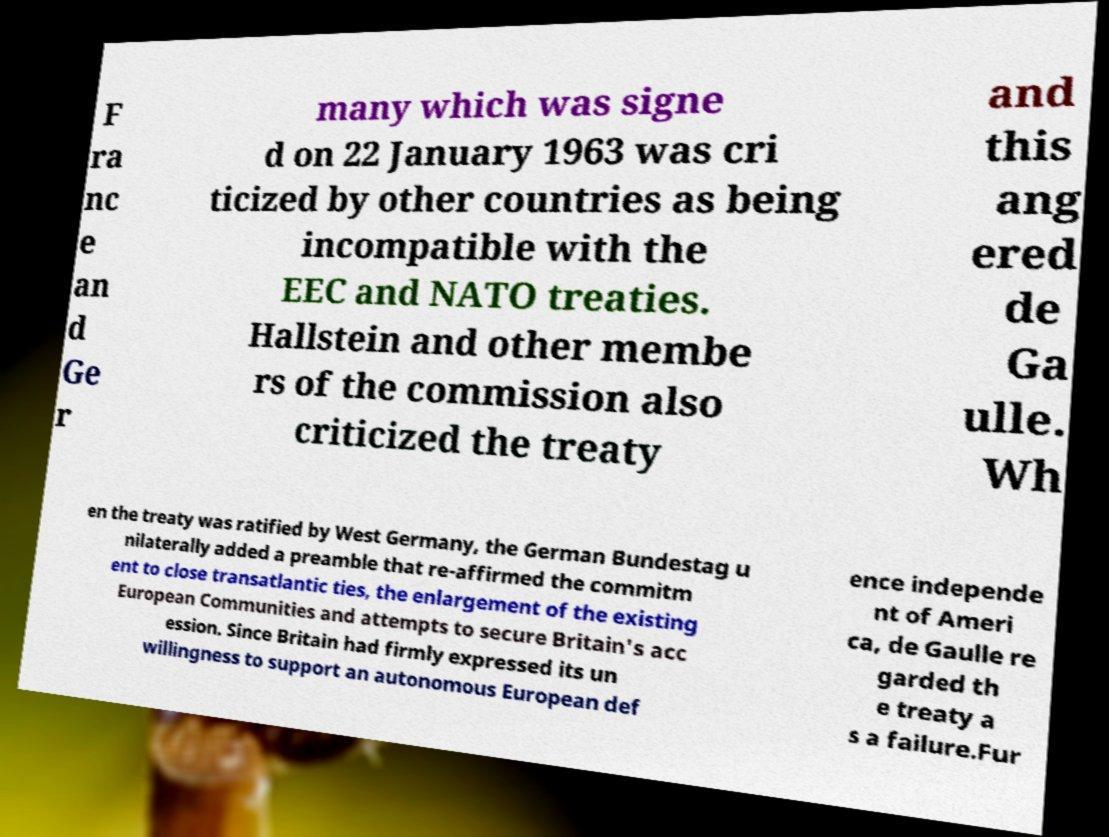Could you assist in decoding the text presented in this image and type it out clearly? F ra nc e an d Ge r many which was signe d on 22 January 1963 was cri ticized by other countries as being incompatible with the EEC and NATO treaties. Hallstein and other membe rs of the commission also criticized the treaty and this ang ered de Ga ulle. Wh en the treaty was ratified by West Germany, the German Bundestag u nilaterally added a preamble that re-affirmed the commitm ent to close transatlantic ties, the enlargement of the existing European Communities and attempts to secure Britain's acc ession. Since Britain had firmly expressed its un willingness to support an autonomous European def ence independe nt of Ameri ca, de Gaulle re garded th e treaty a s a failure.Fur 